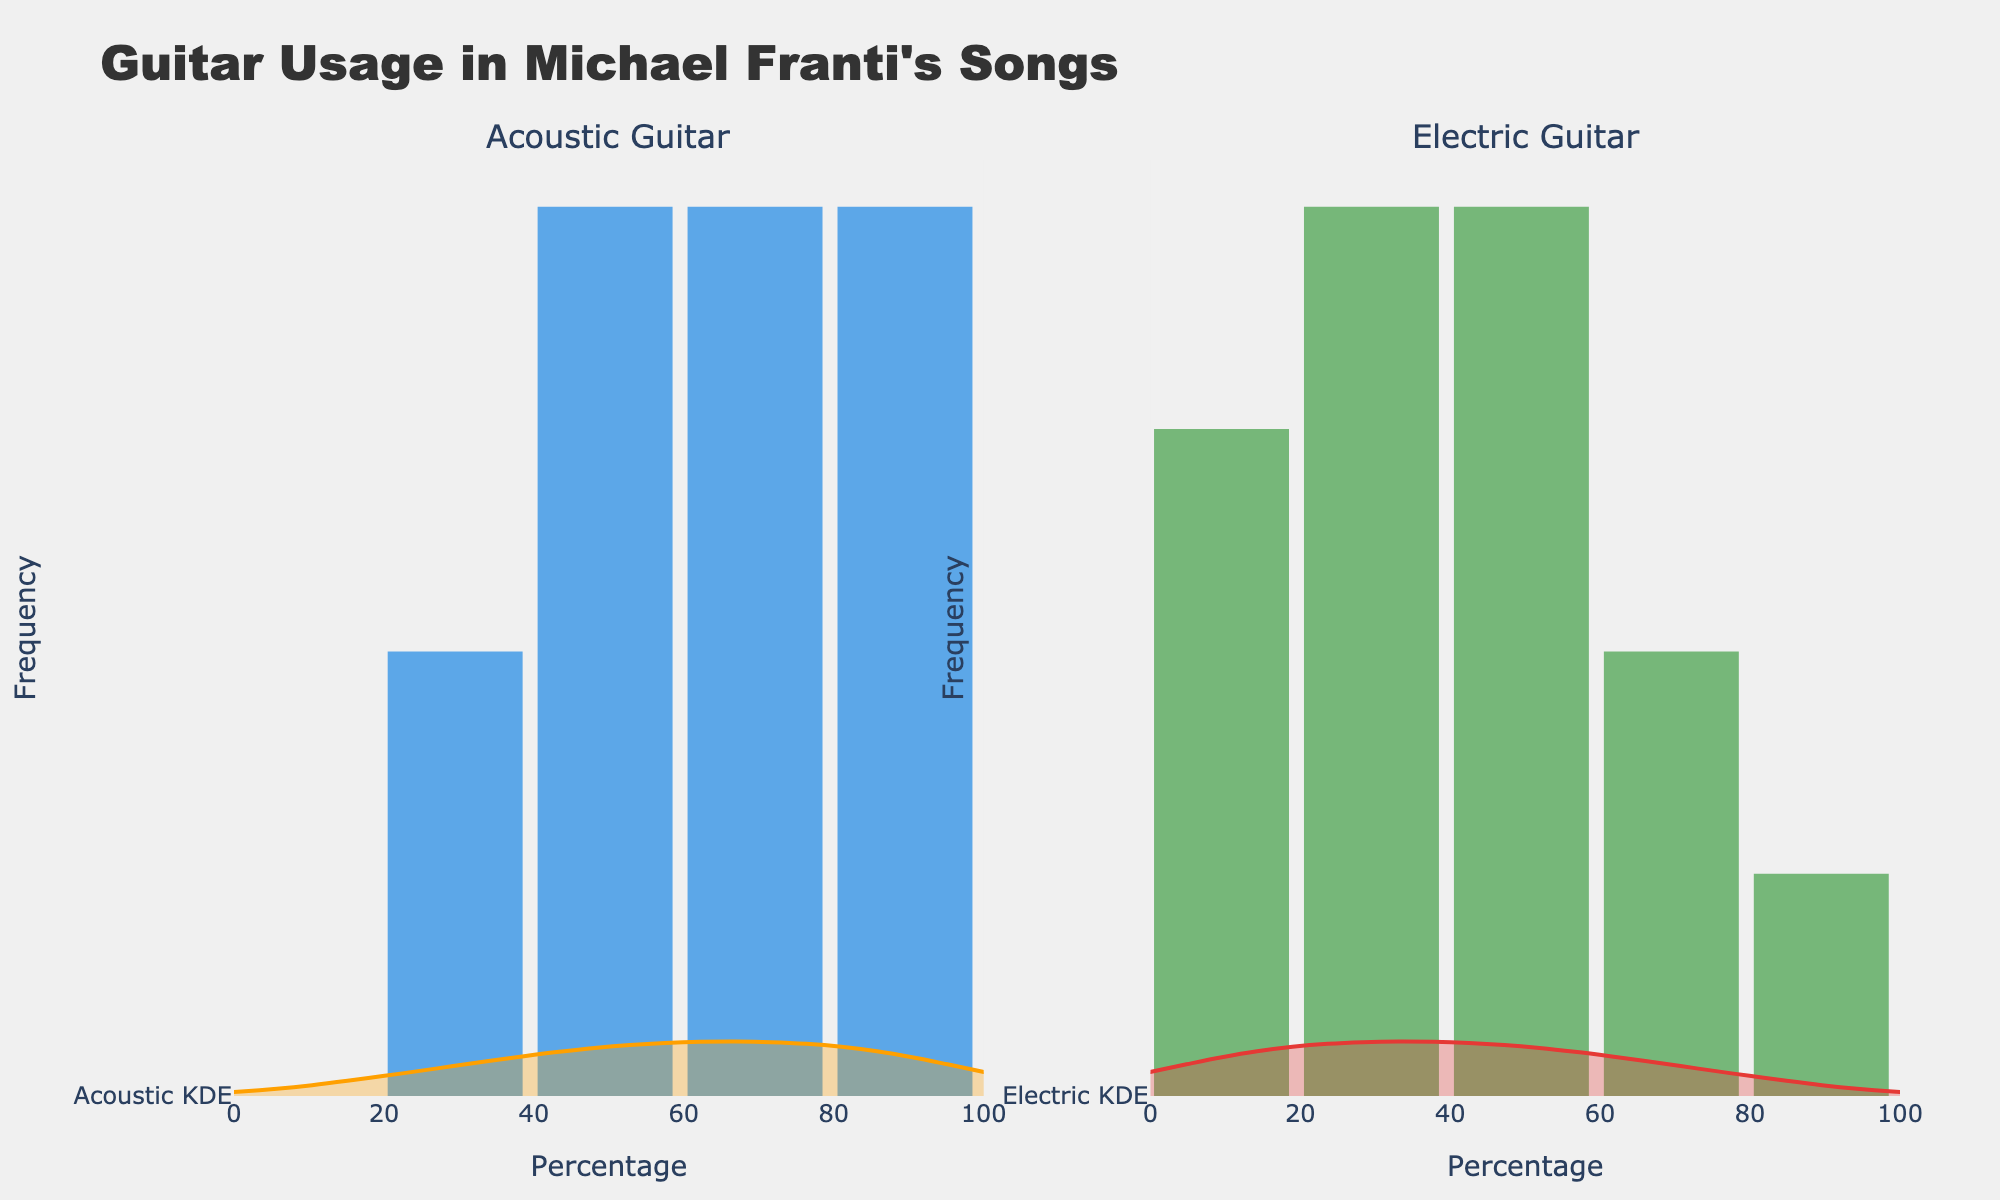What is the title of the figure? The title is usually prominent at the top and provides context for the figure. Here, the title reads "Guitar Usage in Michael Franti's Songs".
Answer: Guitar Usage in Michael Franti's Songs How many subplots are there in the figure? The layout of the figure indicates that there are two distinct sections, each titled separately as "Acoustic Guitar" and "Electric Guitar".
Answer: 2 What do the x-axes represent? The x-axes, labeled "Percentage", indicate the range of guitar usage percentages, from 0 to 100, for both acoustic and electric guitars.
Answer: Percentage Which subplot has a broader range in terms of the density of the KDE curve? Observing the KDE (density curve) widths, the electric guitar subplot's KDE has a broader range of percentages, indicating a wider spread of data compared to the acoustic guitar subplot.
Answer: Electric Guitar Which percentage value for the electric guitar is the most frequent? By examining the histogram bars on the electric guitar subplot, the tallest bar corresponds to the 60% value, indicating it is the most frequent.
Answer: 60% What is the range of the most frequent percentages for the acoustic guitar? The tallest bars in the acoustic guitar histogram are around 60% to 90%, indicating these are the most common percentages.
Answer: 60% to 90% How does the distribution of acoustic guitar usage compare to electric guitar usage? By comparing both histograms and KDE curves, we see that acoustic guitar usage is more concentrated in the higher percentage range, while electric guitar usage is more spread out with peaks around 20% and 60%.
Answer: Acoustic is more concentrated; Electric is more spread out What is the primary color used for the histogram bars of the electric guitar subplot? The colors are visually distinguishable, and the electric guitar histogram bars are green.
Answer: Green What does the presence of the KDE curve alongside the histogram suggest about the data density? The KDE curve provides a smoothed estimate of the data distribution, suggesting where the majority of data points lie without the granularity of the histogram. This helps in understanding the data distribution more fluidly.
Answer: It indicates data density distribution How are the violin plots positioned relative to the histograms in each subplot? The violin plots (representing KDE) are superimposed to the right of the histograms in each subplot, showing the data density alongside the histogram bars.
Answer: Superimposed to the right 